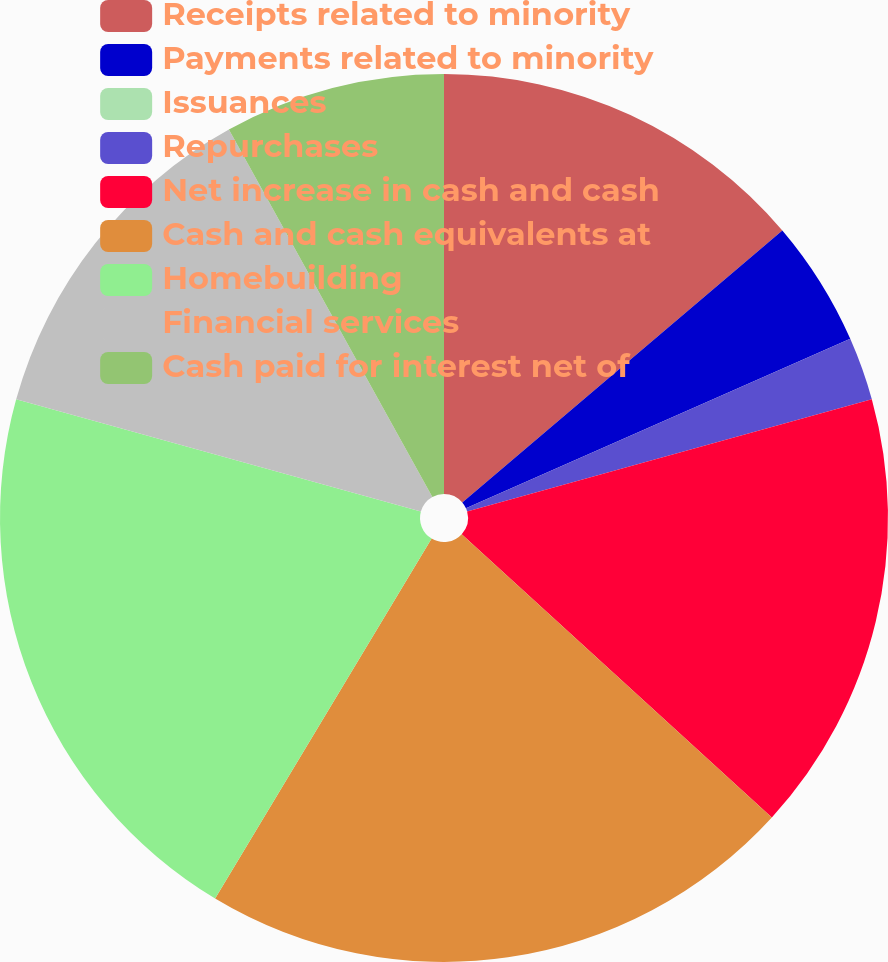<chart> <loc_0><loc_0><loc_500><loc_500><pie_chart><fcel>Receipts related to minority<fcel>Payments related to minority<fcel>Issuances<fcel>Repurchases<fcel>Net increase in cash and cash<fcel>Cash and cash equivalents at<fcel>Homebuilding<fcel>Financial services<fcel>Cash paid for interest net of<nl><fcel>13.79%<fcel>4.6%<fcel>0.0%<fcel>2.3%<fcel>16.09%<fcel>21.84%<fcel>20.69%<fcel>12.64%<fcel>8.05%<nl></chart> 